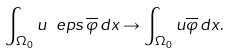<formula> <loc_0><loc_0><loc_500><loc_500>\int _ { \Omega _ { 0 } } u \ e p s \, \overline { \varphi } \, d x \to \int _ { \Omega _ { 0 } } u \overline { \varphi } \, d x .</formula> 